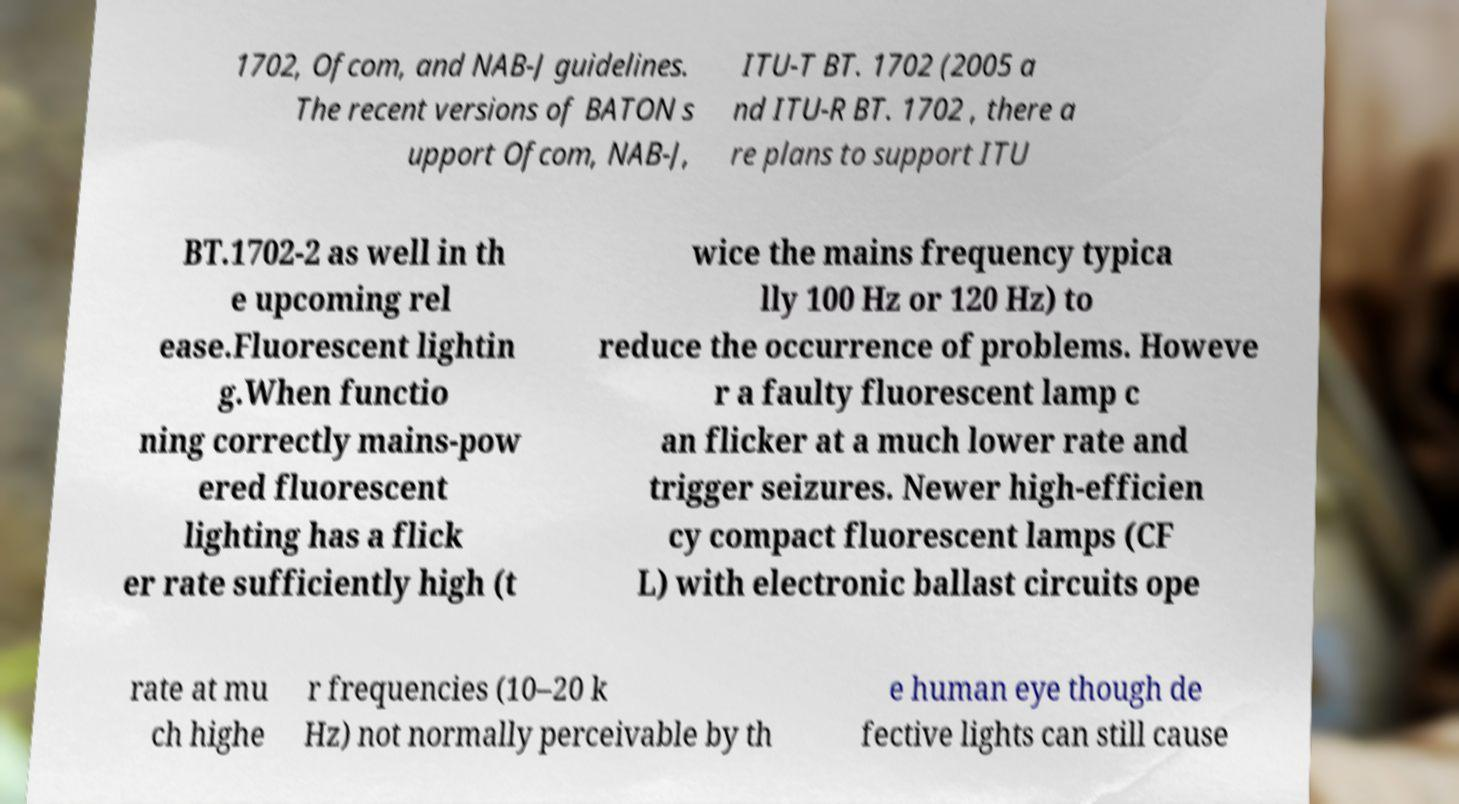Please read and relay the text visible in this image. What does it say? 1702, Ofcom, and NAB-J guidelines. The recent versions of BATON s upport Ofcom, NAB-J, ITU-T BT. 1702 (2005 a nd ITU-R BT. 1702 , there a re plans to support ITU BT.1702-2 as well in th e upcoming rel ease.Fluorescent lightin g.When functio ning correctly mains-pow ered fluorescent lighting has a flick er rate sufficiently high (t wice the mains frequency typica lly 100 Hz or 120 Hz) to reduce the occurrence of problems. Howeve r a faulty fluorescent lamp c an flicker at a much lower rate and trigger seizures. Newer high-efficien cy compact fluorescent lamps (CF L) with electronic ballast circuits ope rate at mu ch highe r frequencies (10–20 k Hz) not normally perceivable by th e human eye though de fective lights can still cause 